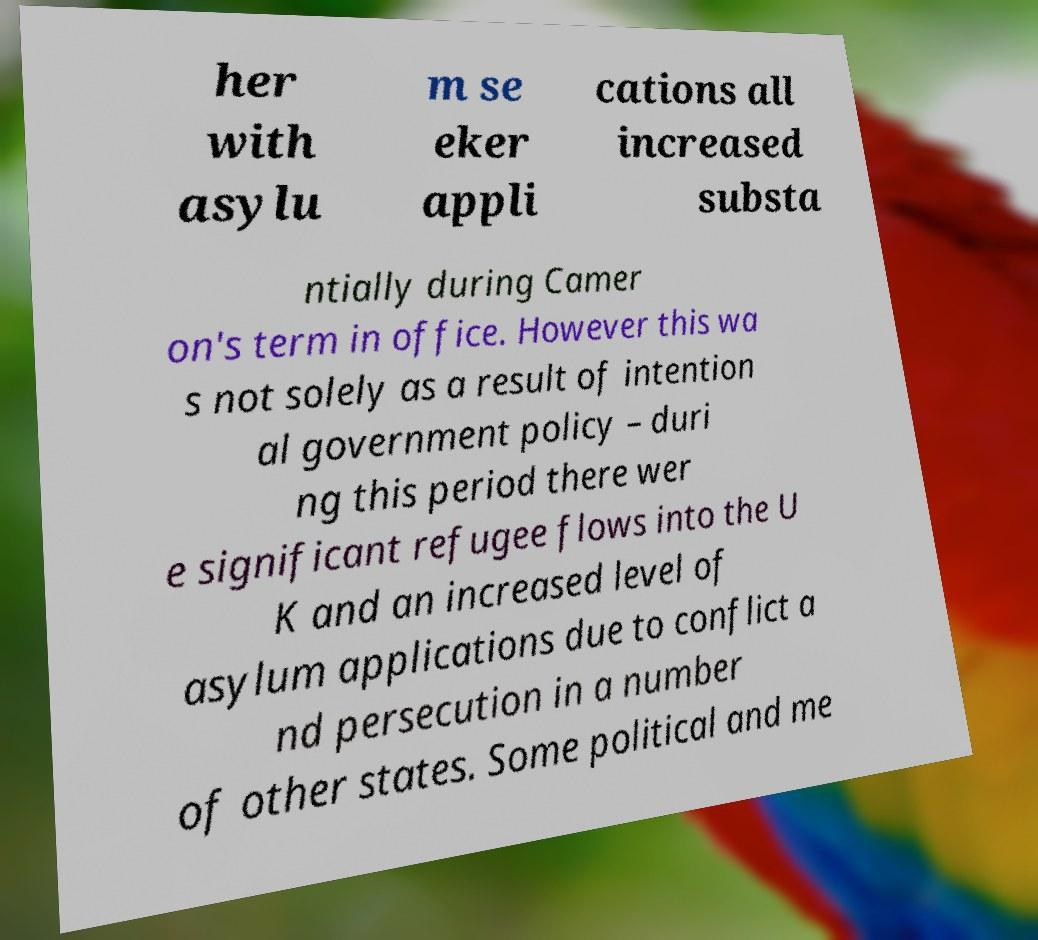There's text embedded in this image that I need extracted. Can you transcribe it verbatim? her with asylu m se eker appli cations all increased substa ntially during Camer on's term in office. However this wa s not solely as a result of intention al government policy – duri ng this period there wer e significant refugee flows into the U K and an increased level of asylum applications due to conflict a nd persecution in a number of other states. Some political and me 